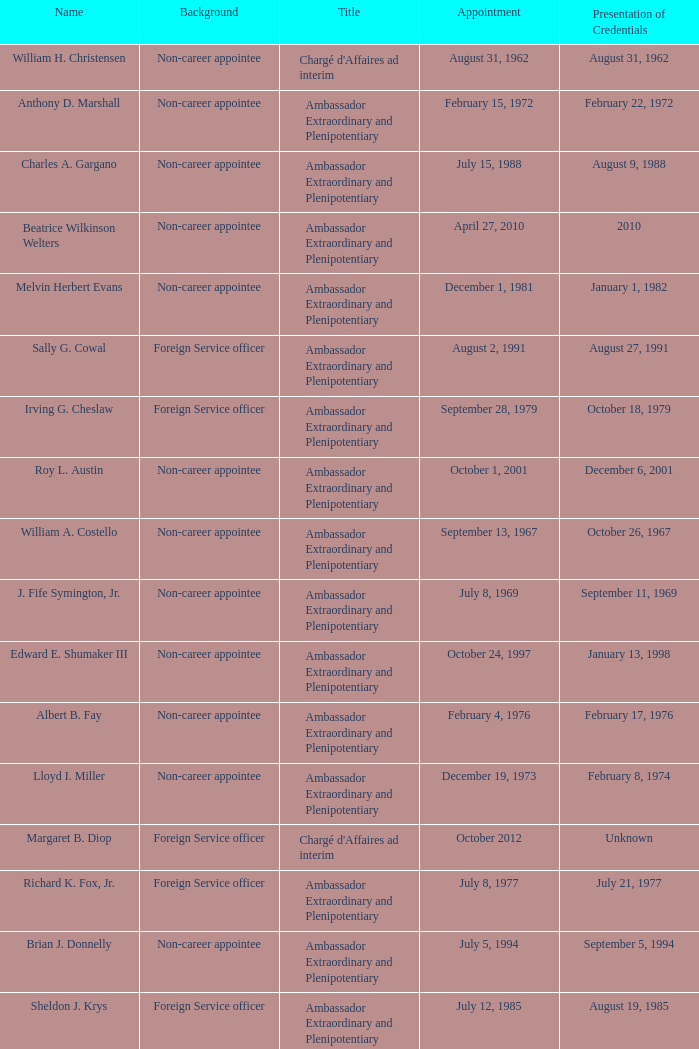On which date did robert g. miner showcase his credentials? December 1, 1962. 